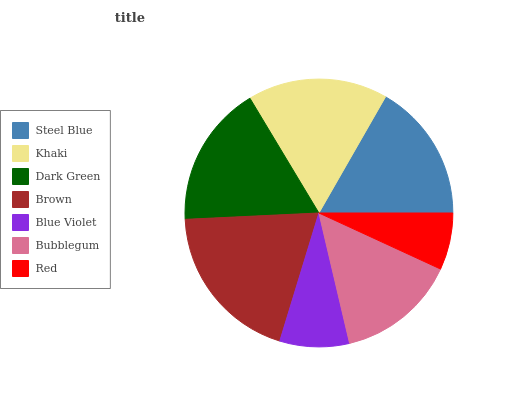Is Red the minimum?
Answer yes or no. Yes. Is Brown the maximum?
Answer yes or no. Yes. Is Khaki the minimum?
Answer yes or no. No. Is Khaki the maximum?
Answer yes or no. No. Is Khaki greater than Steel Blue?
Answer yes or no. Yes. Is Steel Blue less than Khaki?
Answer yes or no. Yes. Is Steel Blue greater than Khaki?
Answer yes or no. No. Is Khaki less than Steel Blue?
Answer yes or no. No. Is Steel Blue the high median?
Answer yes or no. Yes. Is Steel Blue the low median?
Answer yes or no. Yes. Is Dark Green the high median?
Answer yes or no. No. Is Red the low median?
Answer yes or no. No. 